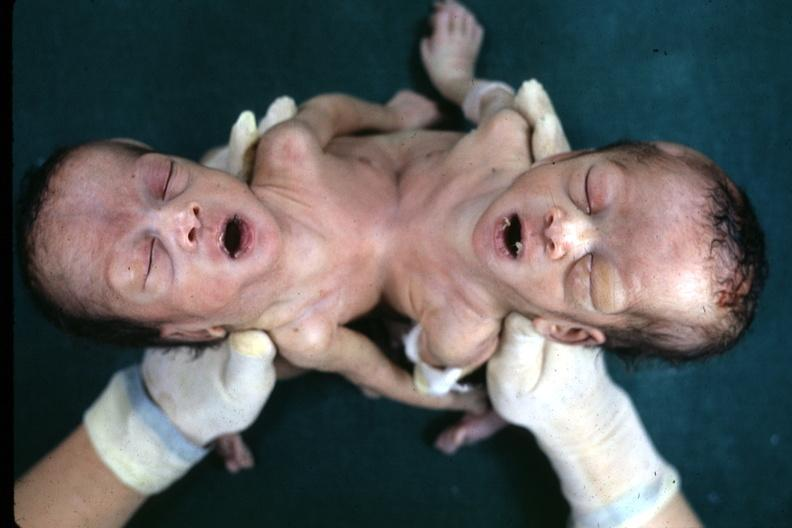what does this image show?
Answer the question using a single word or phrase. View looking down on heads joined lower chest and abdomen 